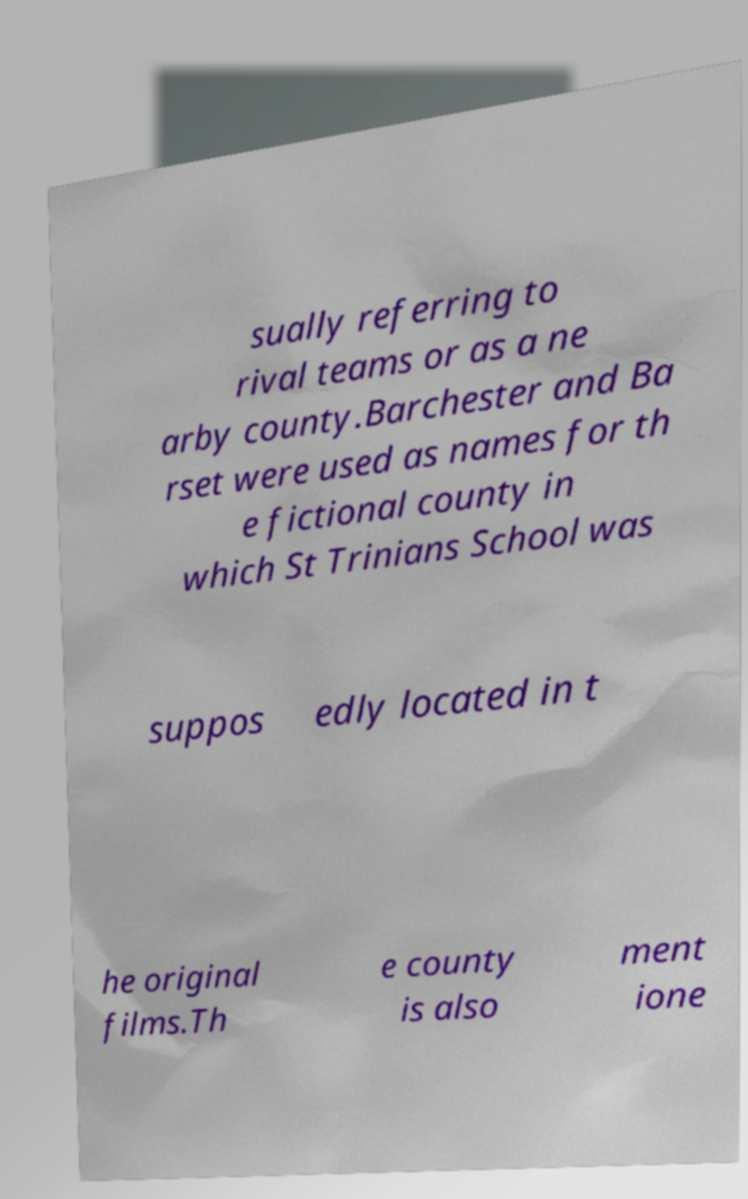Can you read and provide the text displayed in the image?This photo seems to have some interesting text. Can you extract and type it out for me? sually referring to rival teams or as a ne arby county.Barchester and Ba rset were used as names for th e fictional county in which St Trinians School was suppos edly located in t he original films.Th e county is also ment ione 